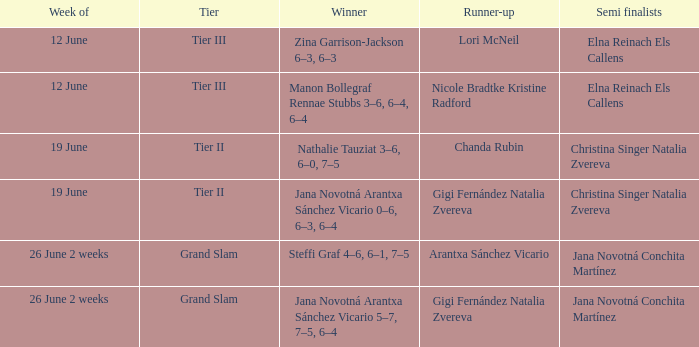When the Tier is listed as tier iii, who is the Winner? Zina Garrison-Jackson 6–3, 6–3, Manon Bollegraf Rennae Stubbs 3–6, 6–4, 6–4. Can you parse all the data within this table? {'header': ['Week of', 'Tier', 'Winner', 'Runner-up', 'Semi finalists'], 'rows': [['12 June', 'Tier III', 'Zina Garrison-Jackson 6–3, 6–3', 'Lori McNeil', 'Elna Reinach Els Callens'], ['12 June', 'Tier III', 'Manon Bollegraf Rennae Stubbs 3–6, 6–4, 6–4', 'Nicole Bradtke Kristine Radford', 'Elna Reinach Els Callens'], ['19 June', 'Tier II', 'Nathalie Tauziat 3–6, 6–0, 7–5', 'Chanda Rubin', 'Christina Singer Natalia Zvereva'], ['19 June', 'Tier II', 'Jana Novotná Arantxa Sánchez Vicario 0–6, 6–3, 6–4', 'Gigi Fernández Natalia Zvereva', 'Christina Singer Natalia Zvereva'], ['26 June 2 weeks', 'Grand Slam', 'Steffi Graf 4–6, 6–1, 7–5', 'Arantxa Sánchez Vicario', 'Jana Novotná Conchita Martínez'], ['26 June 2 weeks', 'Grand Slam', 'Jana Novotná Arantxa Sánchez Vicario 5–7, 7–5, 6–4', 'Gigi Fernández Natalia Zvereva', 'Jana Novotná Conchita Martínez']]} 